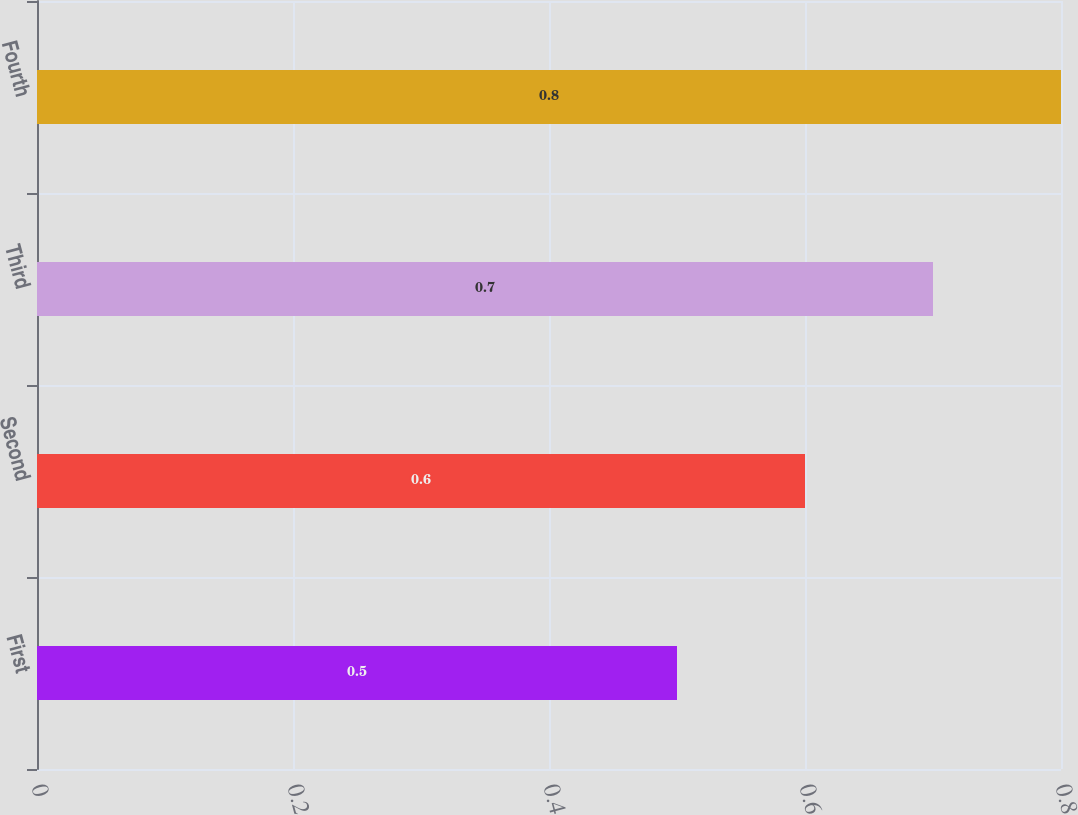<chart> <loc_0><loc_0><loc_500><loc_500><bar_chart><fcel>First<fcel>Second<fcel>Third<fcel>Fourth<nl><fcel>0.5<fcel>0.6<fcel>0.7<fcel>0.8<nl></chart> 